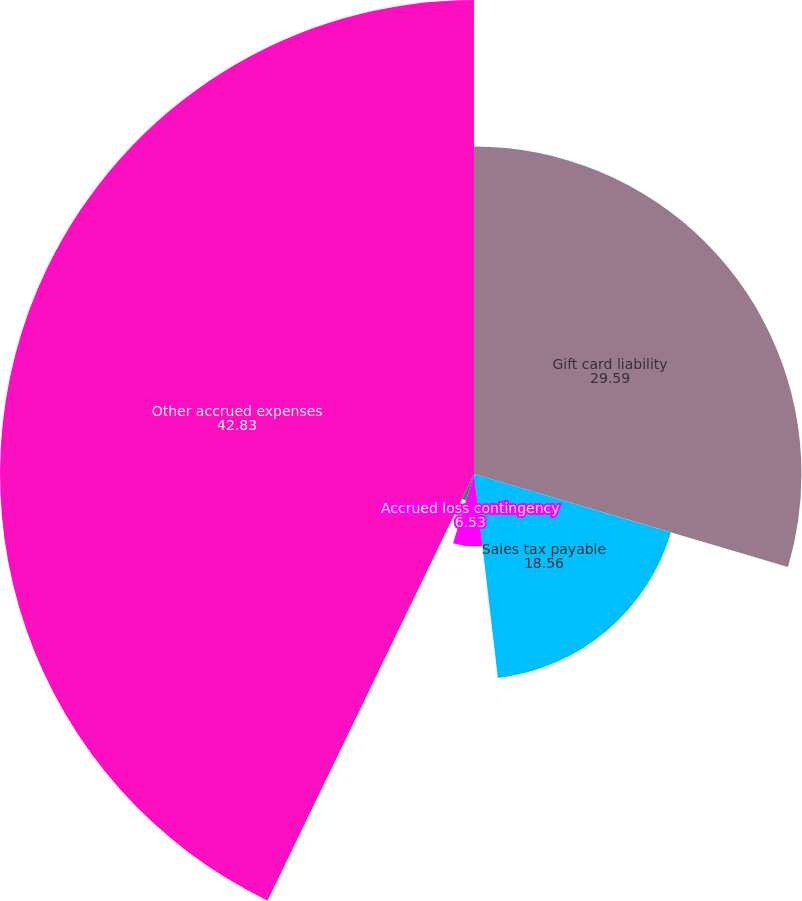<chart> <loc_0><loc_0><loc_500><loc_500><pie_chart><fcel>Gift card liability<fcel>Sales tax payable<fcel>Accrued loss contingency<fcel>Due to McDonald's<fcel>Other accrued expenses<nl><fcel>29.59%<fcel>18.56%<fcel>6.53%<fcel>2.5%<fcel>42.83%<nl></chart> 